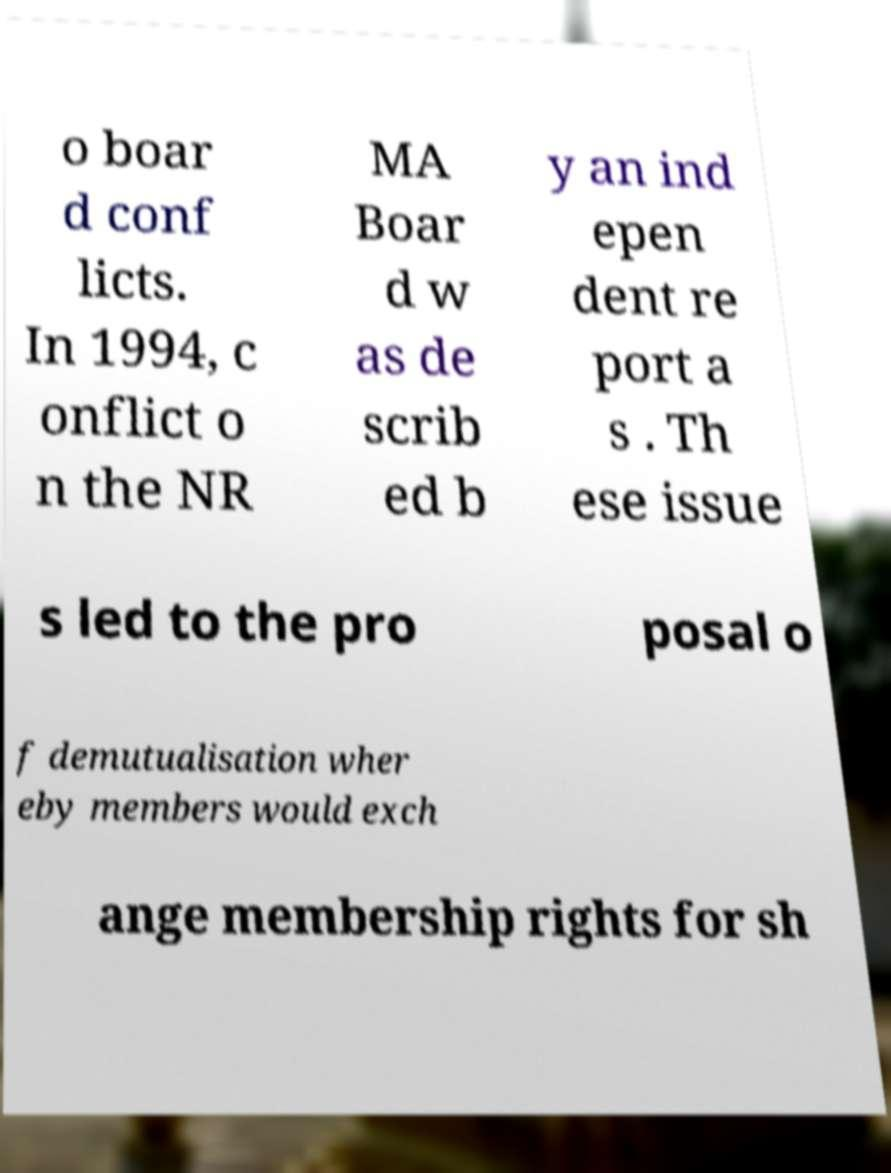Please read and relay the text visible in this image. What does it say? o boar d conf licts. In 1994, c onflict o n the NR MA Boar d w as de scrib ed b y an ind epen dent re port a s . Th ese issue s led to the pro posal o f demutualisation wher eby members would exch ange membership rights for sh 